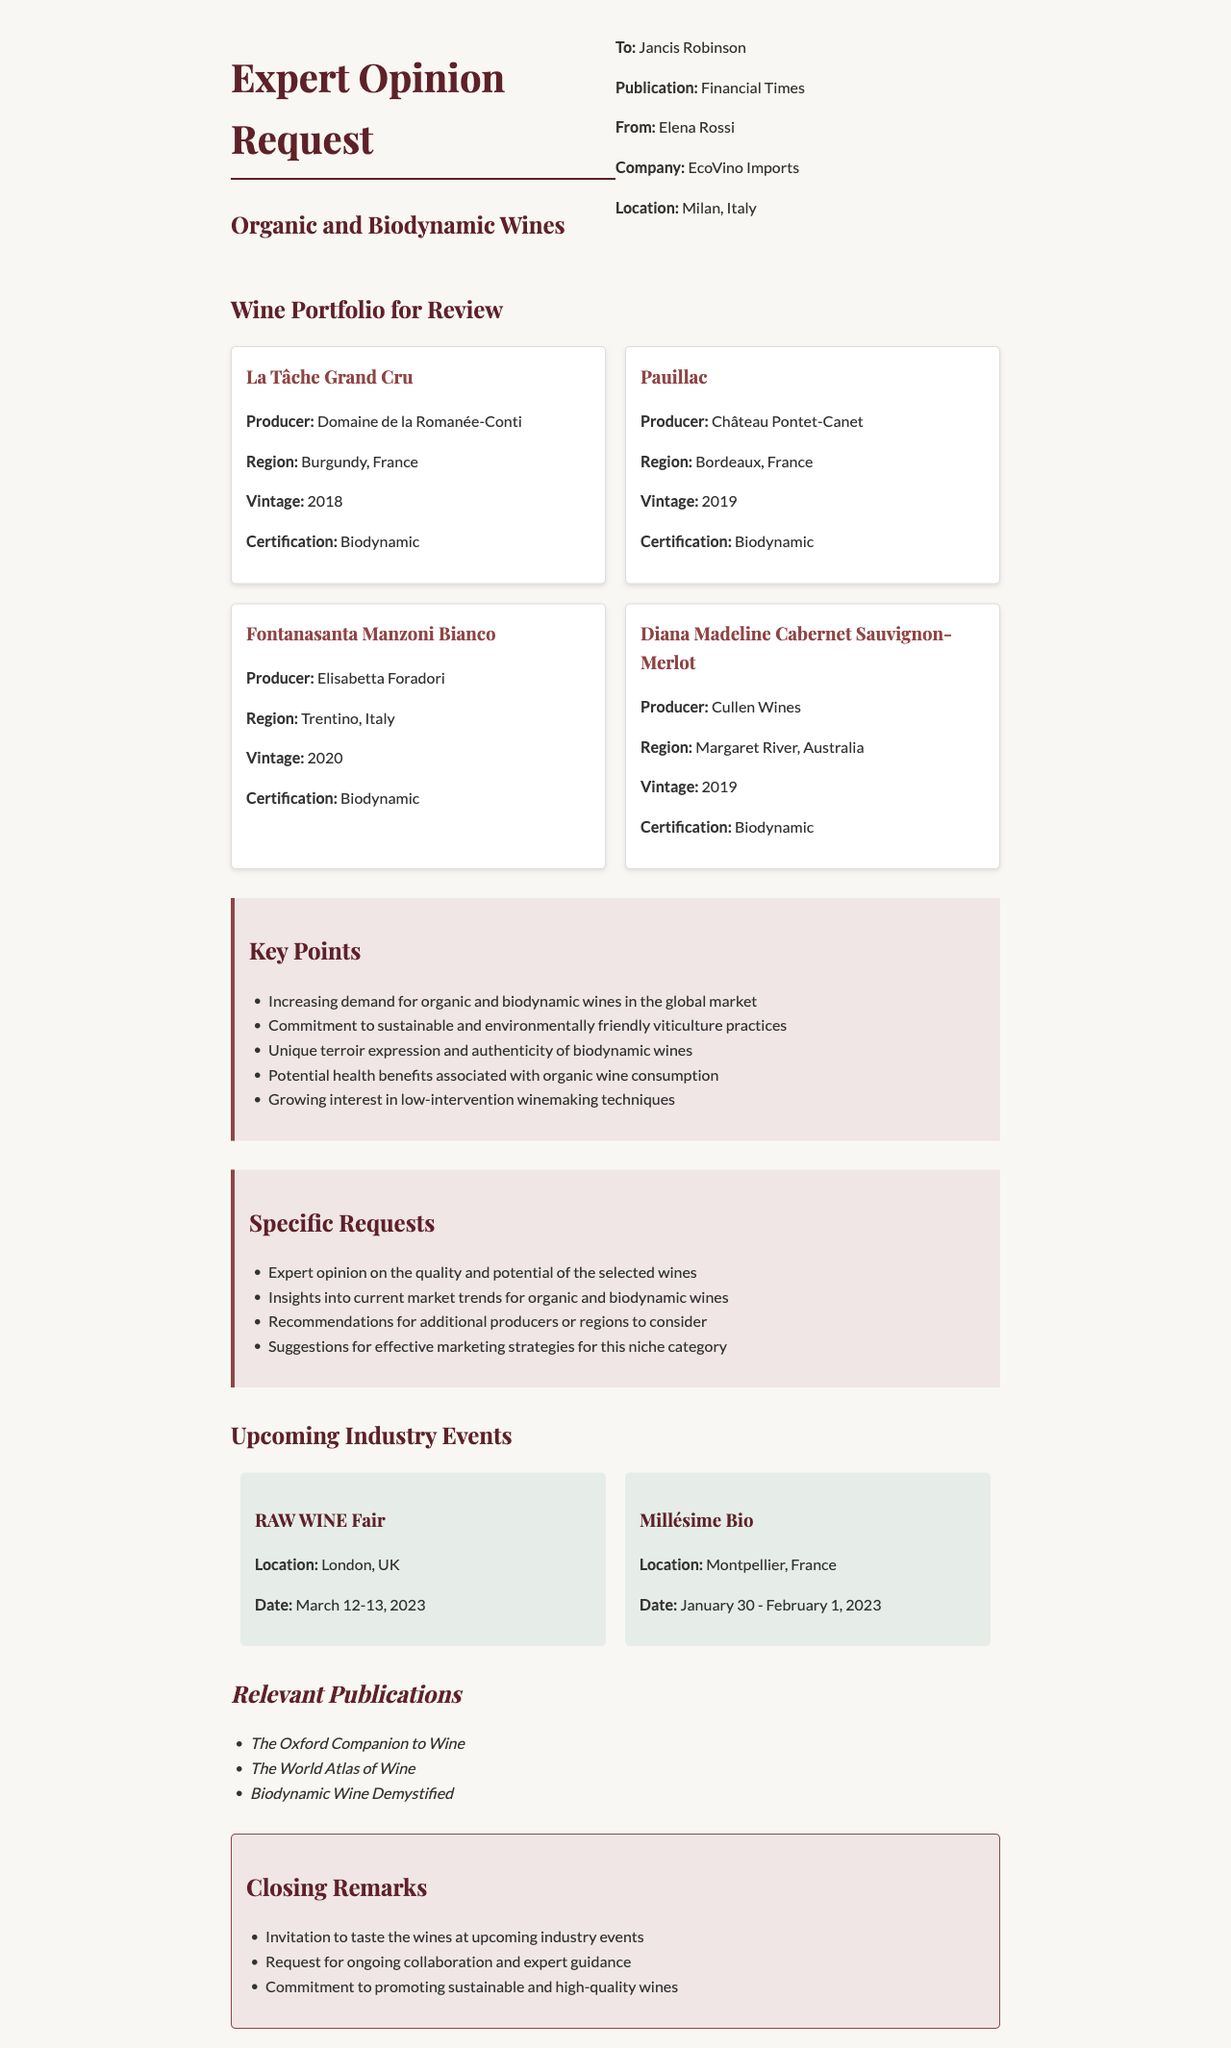What is the name of the distributor? The distributor's name is stated at the beginning of the document.
Answer: Elena Rossi What is the region of the wine "La Tâche Grand Cru"? The region of the wine is found in the description of the wine portfolio.
Answer: Burgundy, France How many wines are listed in the portfolio? The total number of wines can be found in the wine portfolio section of the document.
Answer: 4 What vintage is the "Fontanasanta Manzoni Bianco"? The vintage of the wine is included in the detailed description for that specific wine.
Answer: 2020 What is a key point mentioned regarding biodynamic wines? The key points are summarized under the key points section of the document.
Answer: Unique terroir expression What recommendations does the distributor seek? The specific requests are outlined in a dedicated section of the document.
Answer: Recommendations for additional producers or regions to consider When will the RAW WINE Fair take place? The date for the industry event is detailed in the events section of the document.
Answer: March 12-13, 2023 Which publication is mentioned as relevant? The relevant publications are listed in a specific section of the document.
Answer: The Oxford Companion to Wine What is a closing remark made by the distributor? The closing remarks are detailed in a dedicated section of the document.
Answer: Invitation to taste the wines at upcoming industry events 